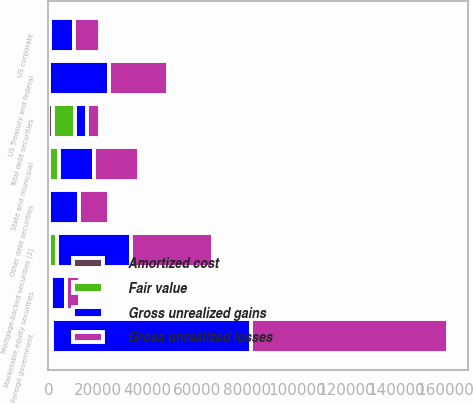Convert chart. <chart><loc_0><loc_0><loc_500><loc_500><stacked_bar_chart><ecel><fcel>Mortgage-backed securities (2)<fcel>US Treasury and federal<fcel>State and municipal<fcel>Foreign government<fcel>US corporate<fcel>Other debt securities<fcel>Total debt securities<fcel>Marketable equity securities<nl><fcel>Gross unrealized losses<fcel>32798<fcel>23702<fcel>18156<fcel>79505<fcel>10258<fcel>12172<fcel>5069<fcel>5768<nl><fcel>Amortized cost<fcel>266<fcel>340<fcel>38<fcel>945<fcel>59<fcel>42<fcel>1690<fcel>554<nl><fcel>Fair value<fcel>3196<fcel>77<fcel>4370<fcel>408<fcel>590<fcel>314<fcel>8955<fcel>459<nl><fcel>Gross unrealized gains<fcel>29868<fcel>23965<fcel>13824<fcel>80042<fcel>9727<fcel>11900<fcel>5069<fcel>5863<nl></chart> 